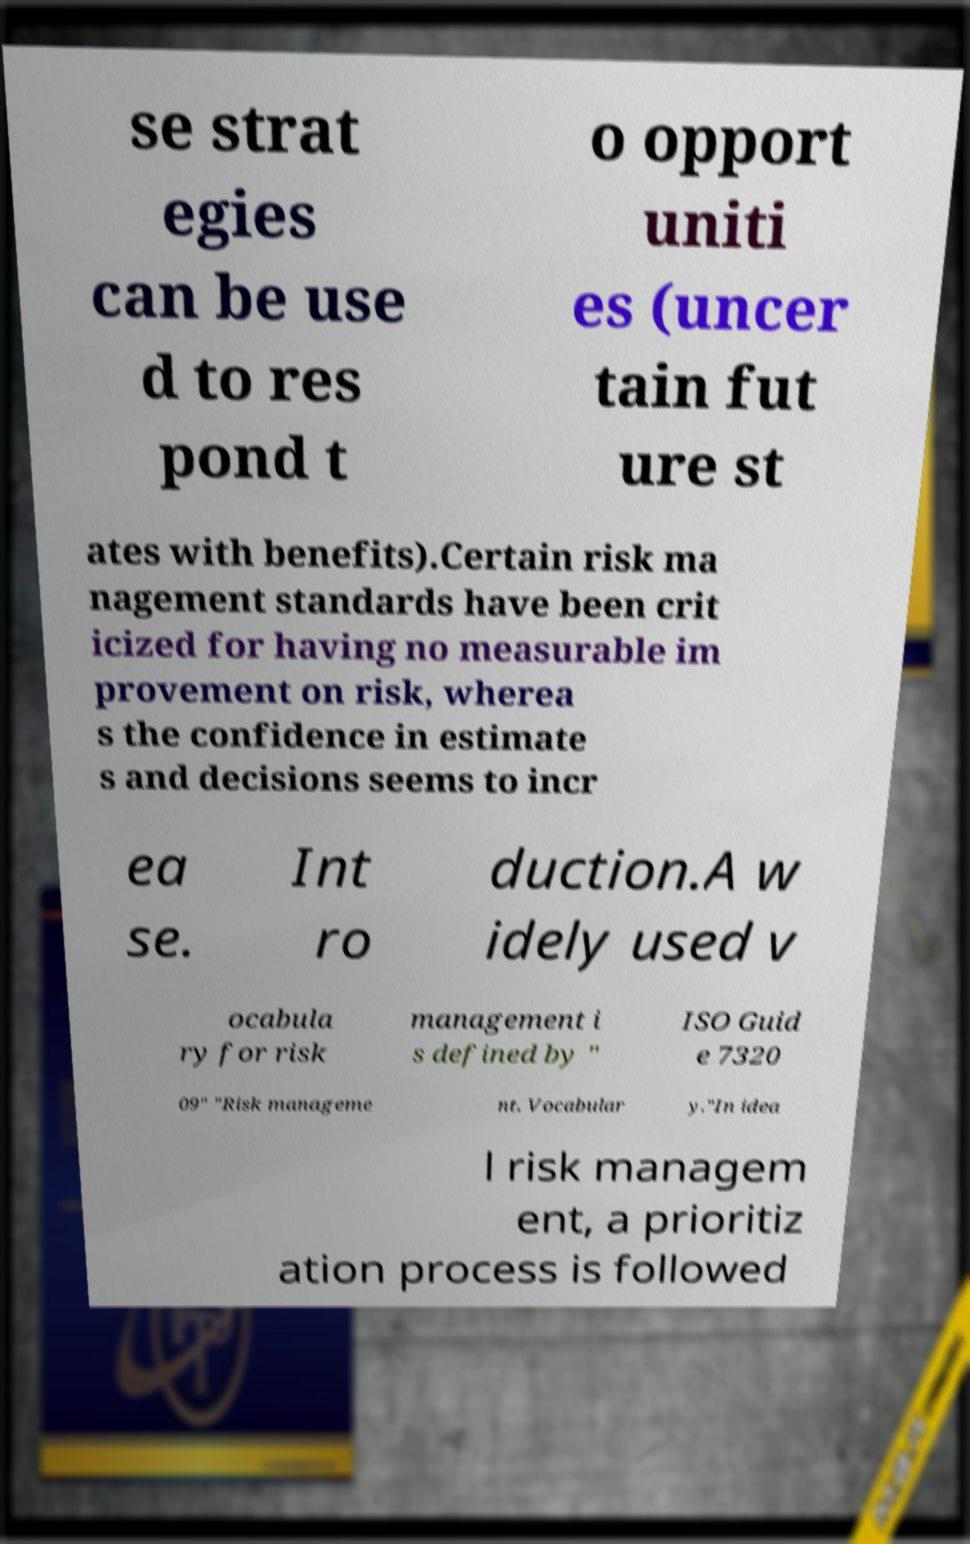Could you assist in decoding the text presented in this image and type it out clearly? se strat egies can be use d to res pond t o opport uniti es (uncer tain fut ure st ates with benefits).Certain risk ma nagement standards have been crit icized for having no measurable im provement on risk, wherea s the confidence in estimate s and decisions seems to incr ea se. Int ro duction.A w idely used v ocabula ry for risk management i s defined by " ISO Guid e 7320 09" "Risk manageme nt. Vocabular y."In idea l risk managem ent, a prioritiz ation process is followed 